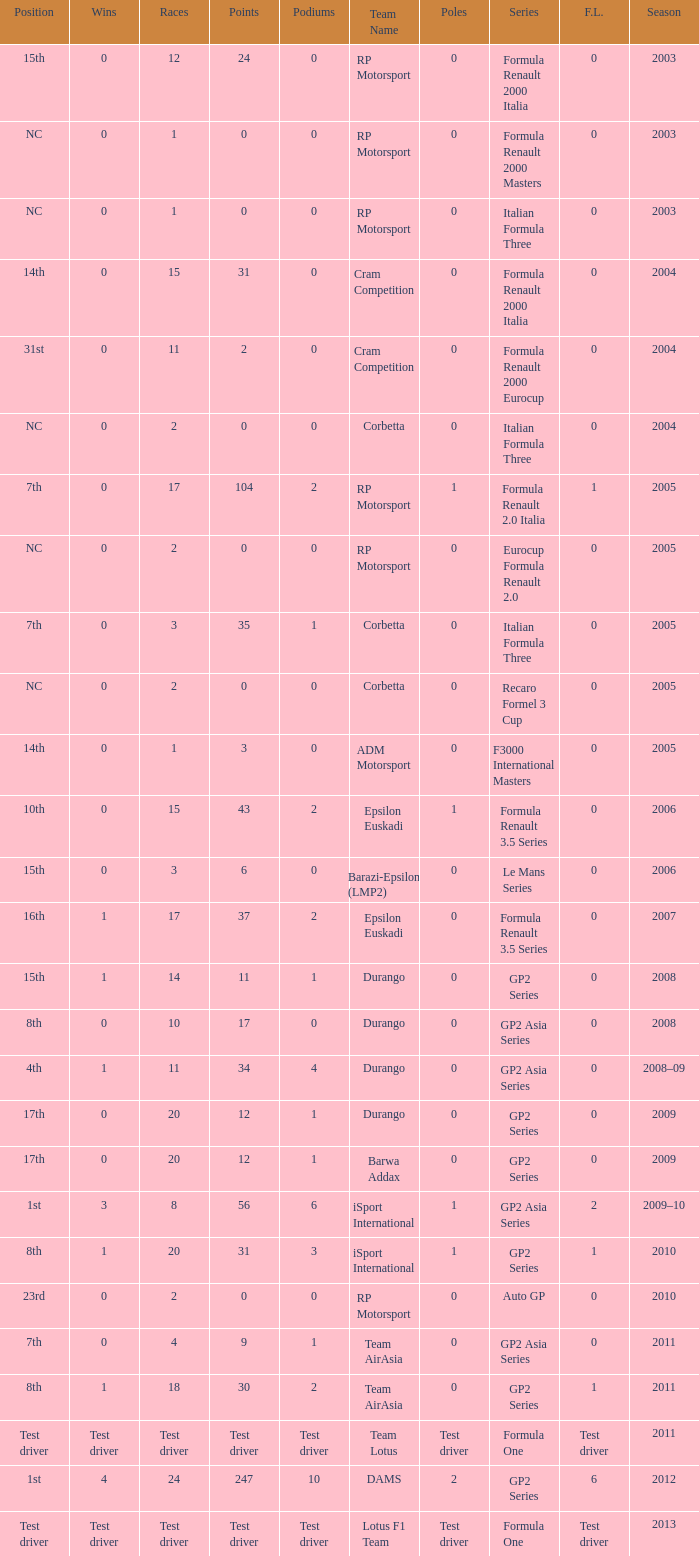What races have gp2 series, 0 F.L. and a 17th position? 20, 20. 